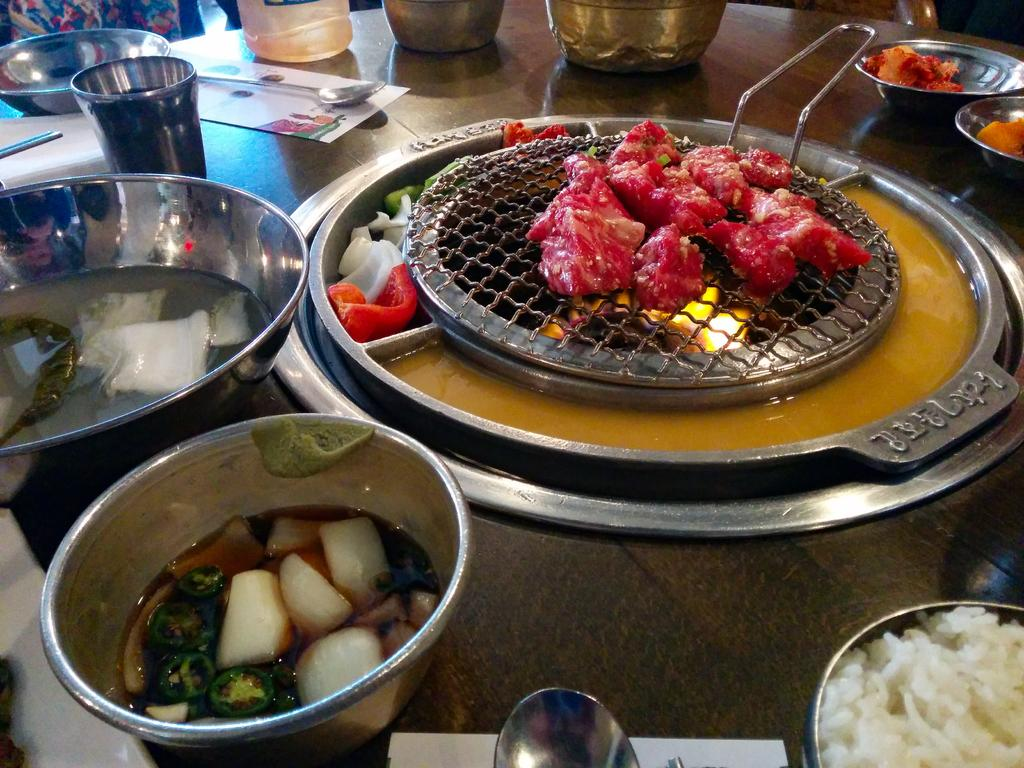What is being cooked on the grill in the image? There is food on the grill in the image. What other food items can be seen in the image? There are additional food items visible around the grill. What type of containers are placed on the table in the image? There are bowls placed on the table in the image. What type of insect is crawling on the food in the image? There is no insect visible on the food in the image. What scientific theory is being discussed around the grill in the image? There is no discussion of a scientific theory in the image; people are likely focused on cooking and enjoying the food. 